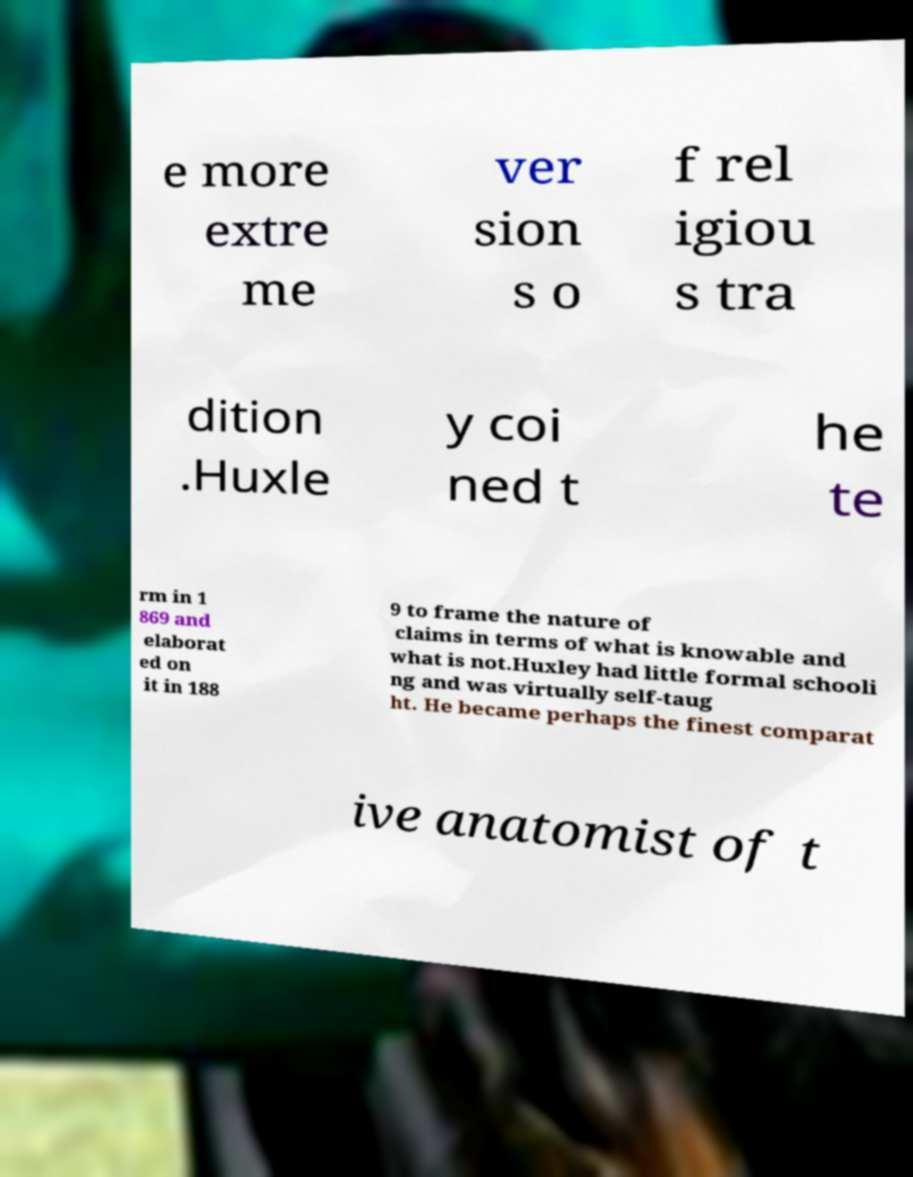Could you extract and type out the text from this image? e more extre me ver sion s o f rel igiou s tra dition .Huxle y coi ned t he te rm in 1 869 and elaborat ed on it in 188 9 to frame the nature of claims in terms of what is knowable and what is not.Huxley had little formal schooli ng and was virtually self-taug ht. He became perhaps the finest comparat ive anatomist of t 